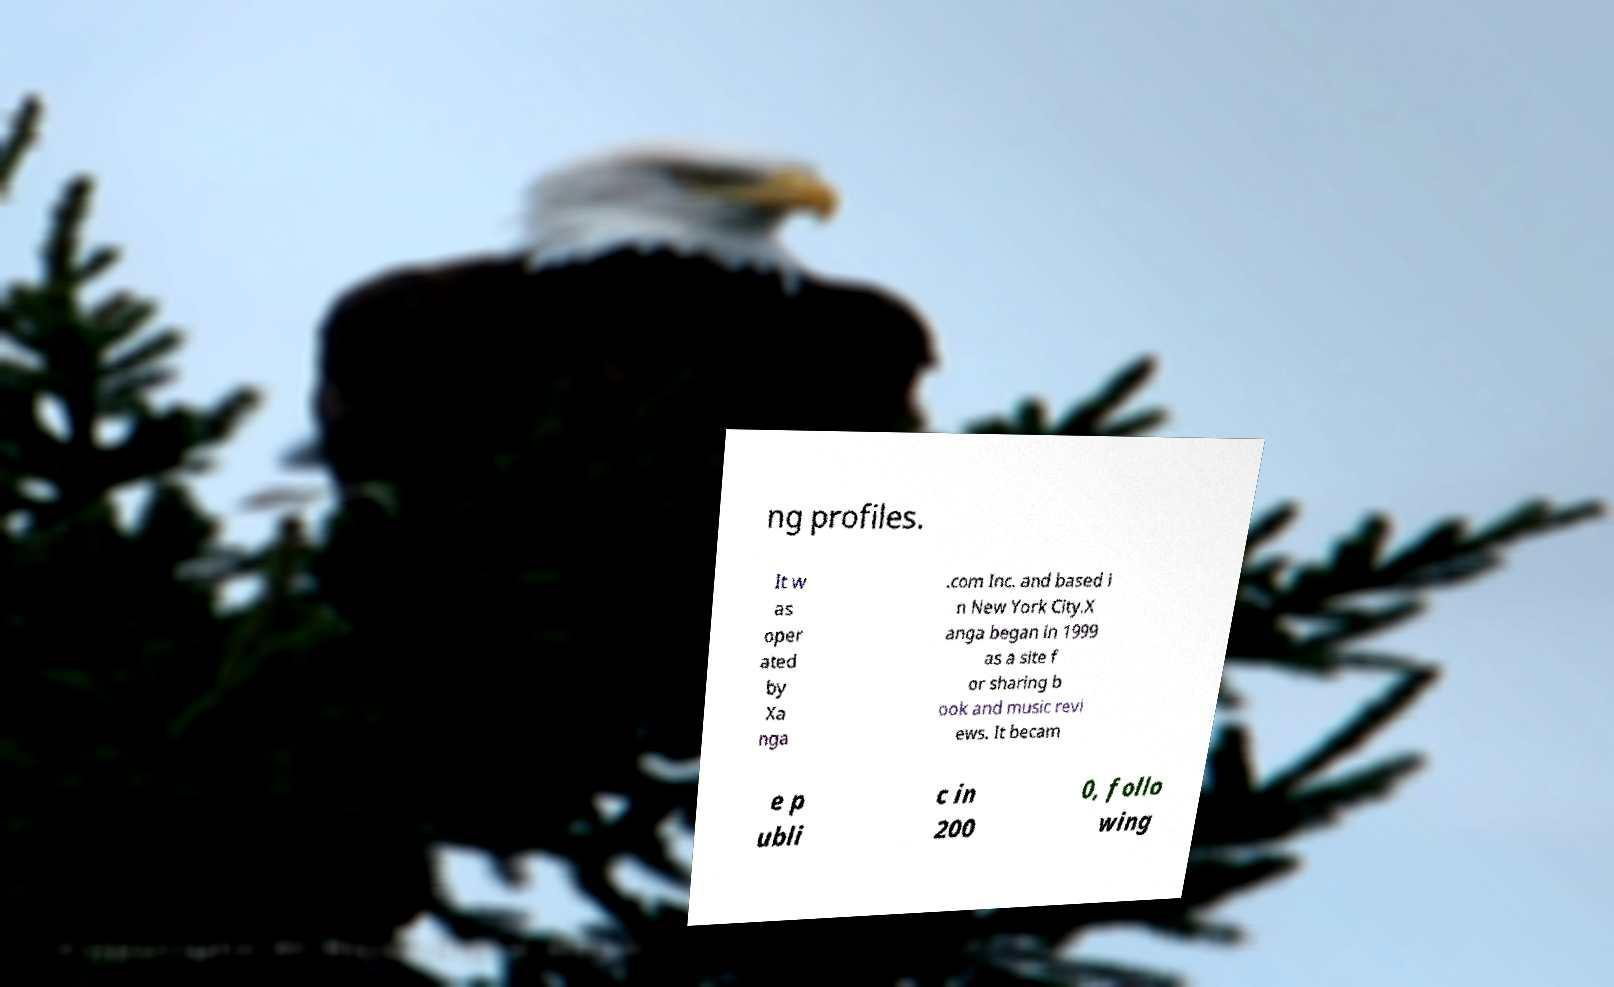Please identify and transcribe the text found in this image. ng profiles. It w as oper ated by Xa nga .com Inc. and based i n New York City.X anga began in 1999 as a site f or sharing b ook and music revi ews. It becam e p ubli c in 200 0, follo wing 